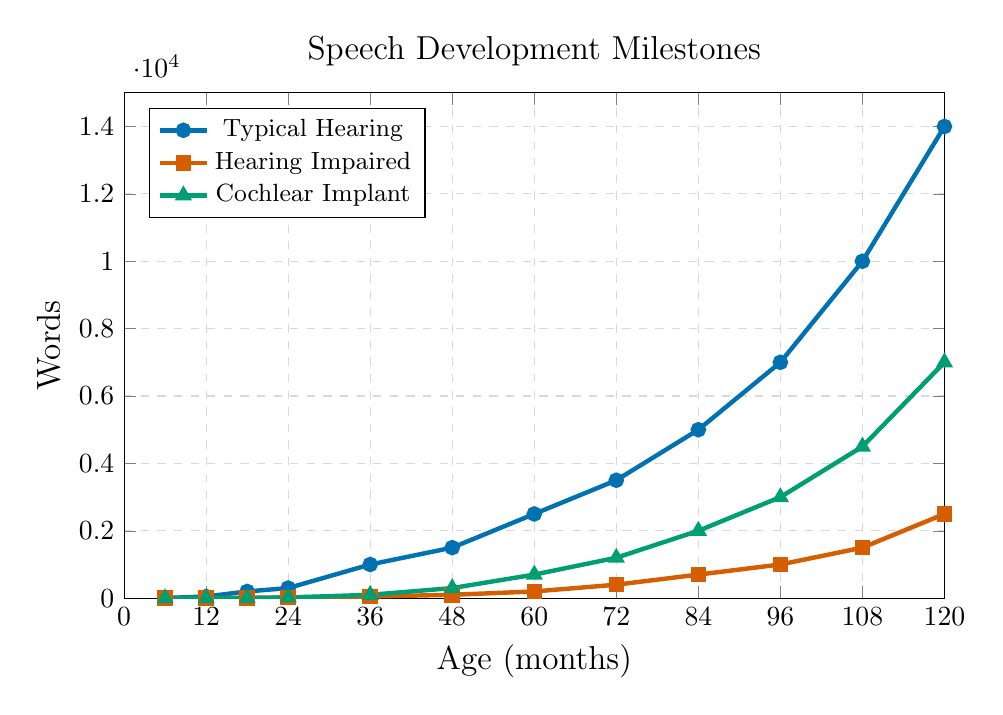What is the age at which children with typical hearing reach 5000 words? Locate the data point on the curve representing "Typical Hearing" where words equal 5000. The corresponding age is 84 months.
Answer: 84 months At 36 months, how many more words can typically hearing children speak compared to hearing-impaired children? Locate the 36-month mark on both the "Typical Hearing" and "Hearing Impaired" curves. At 36 months, typically hearing children can speak 1000 words, and hearing-impaired children can speak 50 words. The difference is 1000 - 50 = 950 words.
Answer: 950 words Which group of children reaches 1000 words first, and at what age? Find the point where each curve reaches 1000 words. Typical hearing children reach this at 36 months, cochlear implant children at 72 months, and hearing-impaired children at 96 months. The typical hearing group reaches it first at 36 months.
Answer: Typical hearing, 36 months What is the difference in word count between cochlear implant children and hearing-impaired children at 72 months? Look at the word counts for both groups at 72 months on their respective curves. Cochlear implant children have 1200 words, and hearing-impaired children have 400 words. The difference is 1200 - 400 = 800 words.
Answer: 800 words On average, how many words can children with hearing impairments speak by the age of 48 months? Locate the word counts for hearing-impaired children from 6 to 48 months and calculate the average. (0 + 3 + 10 + 25 + 50 + 100) / 6 = 188/6 ≈ 31.3 words.
Answer: 31.3 words How many words do cochlear implant children and typically hearing children together know at 120 months? Sum the word counts for both groups at 120 months. Cochlear implant children know 7000 words and typically hearing children know 14000 words. Together, they know 7000 + 14000 = 21000 words.
Answer: 21000 words 